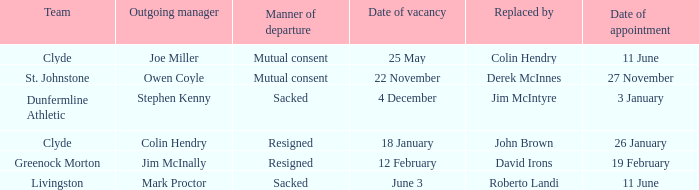Indicate the way of exiting for the appointment scheduled on january 2 Resigned. 